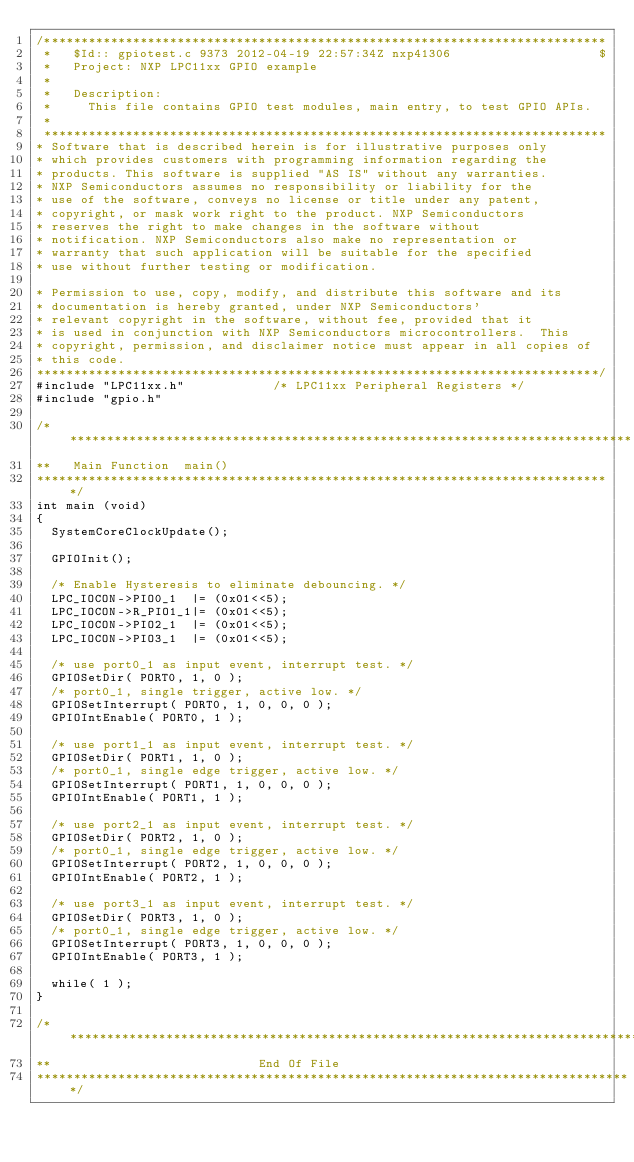<code> <loc_0><loc_0><loc_500><loc_500><_C_>/****************************************************************************
 *   $Id:: gpiotest.c 9373 2012-04-19 22:57:34Z nxp41306                    $
 *   Project: NXP LPC11xx GPIO example
 *
 *   Description:
 *     This file contains GPIO test modules, main entry, to test GPIO APIs.
 *
 ****************************************************************************
* Software that is described herein is for illustrative purposes only
* which provides customers with programming information regarding the
* products. This software is supplied "AS IS" without any warranties.
* NXP Semiconductors assumes no responsibility or liability for the
* use of the software, conveys no license or title under any patent,
* copyright, or mask work right to the product. NXP Semiconductors
* reserves the right to make changes in the software without
* notification. NXP Semiconductors also make no representation or
* warranty that such application will be suitable for the specified
* use without further testing or modification.

* Permission to use, copy, modify, and distribute this software and its 
* documentation is hereby granted, under NXP Semiconductors' 
* relevant copyright in the software, without fee, provided that it 
* is used in conjunction with NXP Semiconductors microcontrollers.  This 
* copyright, permission, and disclaimer notice must appear in all copies of 
* this code.
****************************************************************************/
#include "LPC11xx.h"			/* LPC11xx Peripheral Registers */
#include "gpio.h"

/*****************************************************************************
**   Main Function  main()
******************************************************************************/
int main (void)
{
  SystemCoreClockUpdate();

  GPIOInit();

  /* Enable Hysteresis to eliminate debouncing. */
  LPC_IOCON->PIO0_1  |= (0x01<<5);	
  LPC_IOCON->R_PIO1_1|= (0x01<<5);
  LPC_IOCON->PIO2_1  |= (0x01<<5);
  LPC_IOCON->PIO3_1  |= (0x01<<5);

  /* use port0_1 as input event, interrupt test. */
  GPIOSetDir( PORT0, 1, 0 );
  /* port0_1, single trigger, active low. */
  GPIOSetInterrupt( PORT0, 1, 0, 0, 0 );
  GPIOIntEnable( PORT0, 1 );

  /* use port1_1 as input event, interrupt test. */
  GPIOSetDir( PORT1, 1, 0 );
  /* port0_1, single edge trigger, active low. */
  GPIOSetInterrupt( PORT1, 1, 0, 0, 0 );
  GPIOIntEnable( PORT1, 1 );

  /* use port2_1 as input event, interrupt test. */
  GPIOSetDir( PORT2, 1, 0 );
  /* port0_1, single edge trigger, active low. */
  GPIOSetInterrupt( PORT2, 1, 0, 0, 0 );
  GPIOIntEnable( PORT2, 1 );

  /* use port3_1 as input event, interrupt test. */
  GPIOSetDir( PORT3, 1, 0 );
  /* port0_1, single edge trigger, active low. */
  GPIOSetInterrupt( PORT3, 1, 0, 0, 0 );
  GPIOIntEnable( PORT3, 1 );

  while( 1 );
}

/*********************************************************************************
**                            End Of File
*********************************************************************************/
</code> 